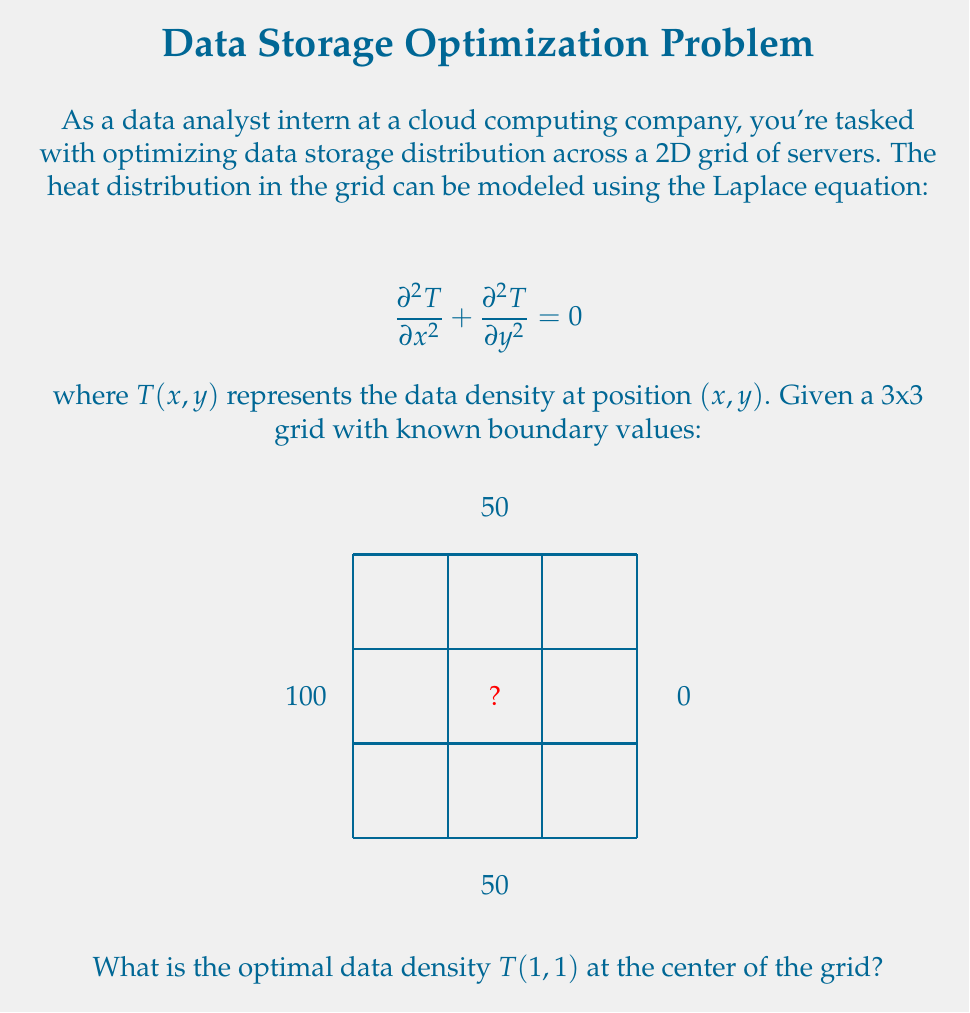Teach me how to tackle this problem. To solve this problem, we'll use the finite difference method to approximate the Laplace equation:

1) For a 3x3 grid, we can approximate the Laplace equation at the center point $(1,1)$ as:

   $$T(0,1) + T(2,1) + T(1,0) + T(1,2) - 4T(1,1) = 0$$

2) We know the boundary values:
   $T(0,1) = 100$
   $T(2,1) = 0$
   $T(1,0) = T(1,2) = 50$

3) Substituting these values into our equation:

   $$100 + 0 + 50 + 50 - 4T(1,1) = 0$$

4) Simplify:
   $$200 - 4T(1,1) = 0$$

5) Solve for $T(1,1)$:
   $$4T(1,1) = 200$$
   $$T(1,1) = 50$$

Thus, the optimal data density at the center of the grid is 50.
Answer: $T(1,1) = 50$ 